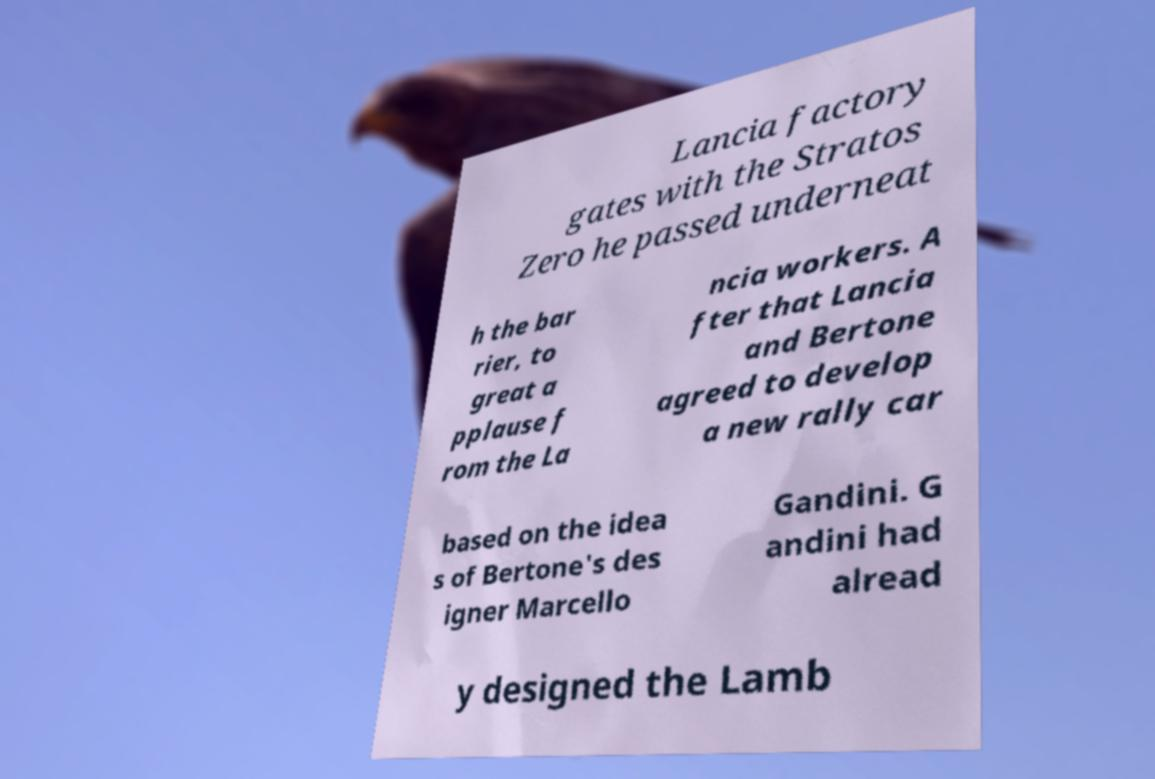Can you accurately transcribe the text from the provided image for me? Lancia factory gates with the Stratos Zero he passed underneat h the bar rier, to great a pplause f rom the La ncia workers. A fter that Lancia and Bertone agreed to develop a new rally car based on the idea s of Bertone's des igner Marcello Gandini. G andini had alread y designed the Lamb 